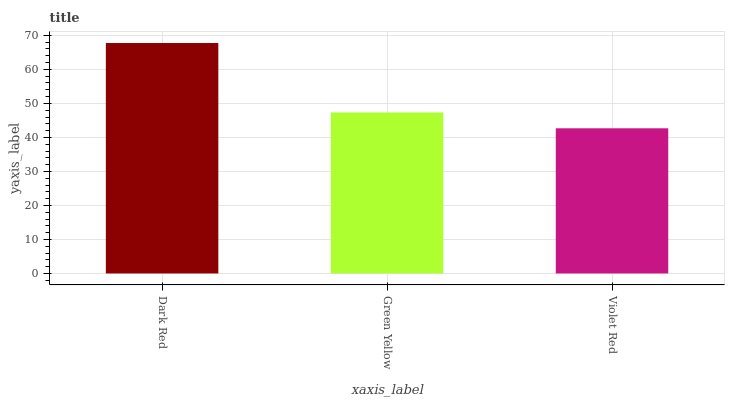Is Violet Red the minimum?
Answer yes or no. Yes. Is Dark Red the maximum?
Answer yes or no. Yes. Is Green Yellow the minimum?
Answer yes or no. No. Is Green Yellow the maximum?
Answer yes or no. No. Is Dark Red greater than Green Yellow?
Answer yes or no. Yes. Is Green Yellow less than Dark Red?
Answer yes or no. Yes. Is Green Yellow greater than Dark Red?
Answer yes or no. No. Is Dark Red less than Green Yellow?
Answer yes or no. No. Is Green Yellow the high median?
Answer yes or no. Yes. Is Green Yellow the low median?
Answer yes or no. Yes. Is Dark Red the high median?
Answer yes or no. No. Is Dark Red the low median?
Answer yes or no. No. 